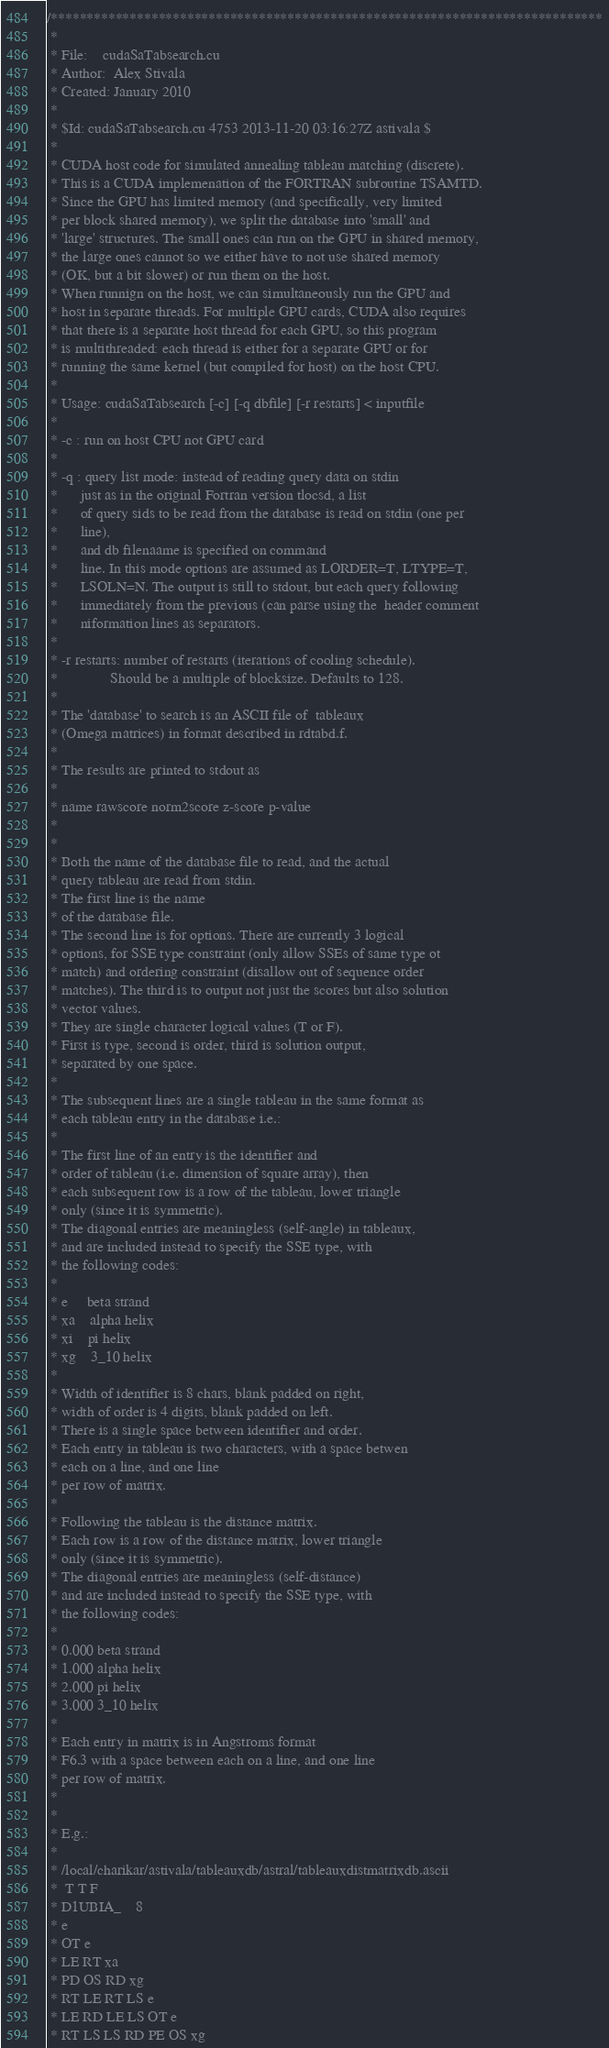<code> <loc_0><loc_0><loc_500><loc_500><_Cuda_>/*****************************************************************************
 * 
 * File:    cudaSaTabsearch.cu
 * Author:  Alex Stivala
 * Created: January 2010
 *
 * $Id: cudaSaTabsearch.cu 4753 2013-11-20 03:16:27Z astivala $
 *
 * CUDA host code for simulated annealing tableau matching (discrete).
 * This is a CUDA implemenation of the FORTRAN subroutine TSAMTD.
 * Since the GPU has limited memory (and specifically, very limited
 * per block shared memory), we split the database into 'small' and
 * 'large' structures. The small ones can run on the GPU in shared memory,
 * the large ones cannot so we either have to not use shared memory
 * (OK, but a bit slower) or run them on the host.
 * When runnign on the host, we can simultaneously run the GPU and
 * host in separate threads. For multiple GPU cards, CUDA also requires
 * that there is a separate host thread for each GPU, so this program
 * is multithreaded: each thread is either for a separate GPU or for
 * running the same kernel (but compiled for host) on the host CPU.
 *
 * Usage: cudaSaTabsearch [-c] [-q dbfile] [-r restarts] < inputfile
 *
 * -c : run on host CPU not GPU card
 *
 * -q : query list mode: instead of reading query data on stdin
 *      just as in the original Fortran version tlocsd, a list
 *      of query sids to be read from the database is read on stdin (one per
 *      line),
 *      and db filenaame is specified on command
 *      line. In this mode options are assumed as LORDER=T, LTYPE=T,
 *      LSOLN=N. The output is still to stdout, but each query following
 *      immediately from the previous (can parse using the  header comment
 *      niformation lines as separators.
 *
 * -r restarts: number of restarts (iterations of cooling schedule).
 *              Should be a multiple of blocksize. Defaults to 128.
 *
 * The 'database' to search is an ASCII file of  tableaux
 * (Omega matrices) in format described in rdtabd.f.
 *
 * The results are printed to stdout as 
 *
 * name rawscore norm2score z-score p-value
 *
 *
 * Both the name of the database file to read, and the actual
 * query tableau are read from stdin. 
 * The first line is the name
 * of the database file.
 * The second line is for options. There are currently 3 logical
 * options, for SSE type constraint (only allow SSEs of same type ot
 * match) and ordering constraint (disallow out of sequence order 
 * matches). The third is to output not just the scores but also solution
 * vector values.
 * They are single character logical values (T or F).
 * First is type, second is order, third is solution output,
 * separated by one space.
 *
 * The subsequent lines are a single tableau in the same format as
 * each tableau entry in the database i.e.:
 *
 * The first line of an entry is the identifier and
 * order of tableau (i.e. dimension of square array), then
 * each subsequent row is a row of the tableau, lower triangle
 * only (since it is symmetric).
 * The diagonal entries are meaningless (self-angle) in tableaux,
 * and are included instead to specify the SSE type, with
 * the following codes:
 *
 * e     beta strand
 * xa    alpha helix
 * xi    pi helix
 * xg    3_10 helix
 *
 * Width of identifier is 8 chars, blank padded on right,
 * width of order is 4 digits, blank padded on left.
 * There is a single space between identifier and order.
 * Each entry in tableau is two characters, with a space betwen
 * each on a line, and one line
 * per row of matrix.
 *
 * Following the tableau is the distance matrix.
 * Each row is a row of the distance matrix, lower triangle
 * only (since it is symmetric).
 * The diagonal entries are meaningless (self-distance)
 * and are included instead to specify the SSE type, with
 * the following codes:
 * 
 * 0.000 beta strand
 * 1.000 alpha helix
 * 2.000 pi helix
 * 3.000 3_10 helix
 * 
 * Each entry in matrix is in Angstroms format
 * F6.3 with a space between each on a line, and one line
 * per row of matrix.
 * 
 * 
 * E.g.:
 * 
 * /local/charikar/astivala/tableauxdb/astral/tableauxdistmatrixdb.ascii
 *  T T F
 * D1UBIA_    8
 * e  
 * OT e  
 * LE RT xa 
 * PD OS RD xg 
 * RT LE RT LS e  
 * LE RD LE LS OT e  
 * RT LS LS RD PE OS xg </code> 